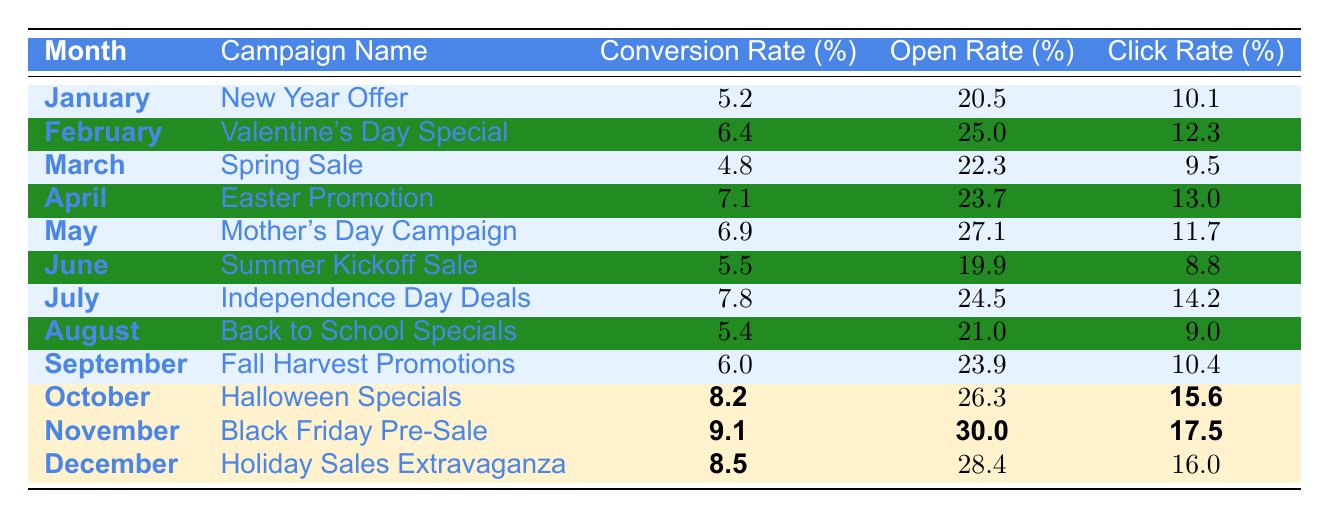What was the highest conversion rate in 2023? The table indicates that the highest conversion rate is 9.1, recorded in November with the "Black Friday Pre-Sale" campaign.
Answer: 9.1 Which month had the lowest click rate? By examining the click rates listed, March has the lowest click rate at 9.5%.
Answer: 9.5% What is the average conversion rate for the months of January to June? The conversion rates for those months are 5.2, 6.4, 4.8, 7.1, 6.9, and 5.5. Summing these values gives 36.9, which divided by 6 results in an average of 6.15.
Answer: 6.15 Did the conversion rate increase from July to August? Looking at the data, July has a conversion rate of 7.8 and August has 5.4. Since 7.8 is greater than 5.4, the conversion rate did not increase; it actually decreased.
Answer: No What are the conversion rates for the months that have a conversion rate greater than 7%? The months with conversion rates greater than 7% are April (7.1), July (7.8), November (9.1), and December (8.5).
Answer: 7.1, 7.8, 9.1, 8.5 What is the difference in open rates between the campaigns with the highest and lowest conversion rates? The campaign with the highest conversion rate (November) has an open rate of 30.0%, while the campaign with the lowest conversion rate (March) has an open rate of 22.3%. The difference is 30.0 - 22.3 = 7.7.
Answer: 7.7 Was there a month where the conversion rate and click rate were both above 10%? None of the months had both rates above 10%. The highest click rate is 17.5% (November), but the conversion rate for all months stays below 10% except for November.
Answer: No How many months had a conversion rate less than 6%? Referring to the table, January (5.2%), March (4.8%), and June (5.5%) all had conversion rates less than 6%. That’s a total of 3 months.
Answer: 3 What was the trend in conversion rates from January to December? The conversion rates fluctuate throughout the months, starting at 5.2% in January, peaking at 9.1% in November, and showing a mix of increases and decreases across the months.
Answer: Fluctuating Which campaign had the highest open rate? The Black Friday Pre-Sale in November had the highest open rate at 30.0%.
Answer: 30.0% 